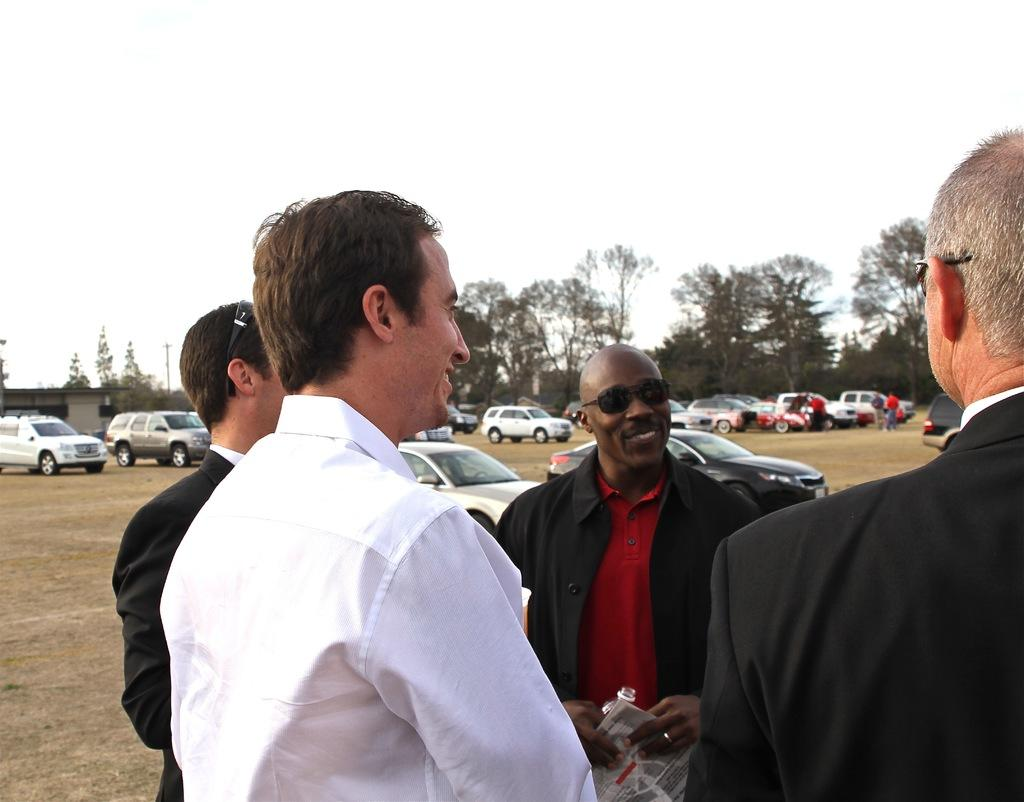What can be observed about the people in the image? There are people standing in the image. Can you describe the appearance of one of the individuals? A man is wearing sunglasses in the image. What type of vehicles are present in the image? There are cars parked in the image. What natural elements can be seen in the image? There are trees visible in the image. What type of building is present in the image? There is a house in the image. How would you describe the weather based on the image? The sky is cloudy in the image. Can you tell me how many keys are hanging on the tree in the image? There are no keys visible in the image; only people, cars, trees, a house, and a cloudy sky are present. 